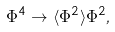<formula> <loc_0><loc_0><loc_500><loc_500>\Phi ^ { 4 } \rightarrow \langle \Phi ^ { 2 } \rangle \Phi ^ { 2 } ,</formula> 